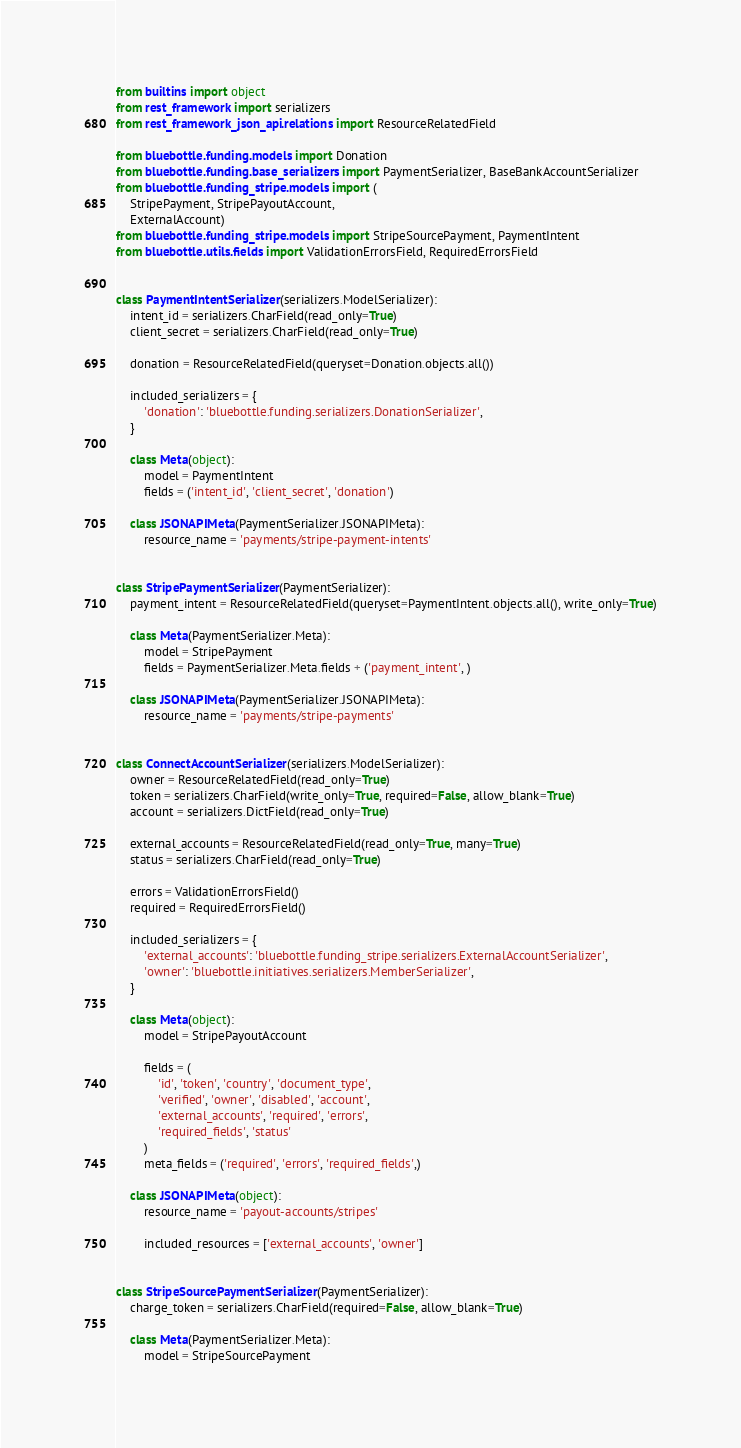Convert code to text. <code><loc_0><loc_0><loc_500><loc_500><_Python_>from builtins import object
from rest_framework import serializers
from rest_framework_json_api.relations import ResourceRelatedField

from bluebottle.funding.models import Donation
from bluebottle.funding.base_serializers import PaymentSerializer, BaseBankAccountSerializer
from bluebottle.funding_stripe.models import (
    StripePayment, StripePayoutAccount,
    ExternalAccount)
from bluebottle.funding_stripe.models import StripeSourcePayment, PaymentIntent
from bluebottle.utils.fields import ValidationErrorsField, RequiredErrorsField


class PaymentIntentSerializer(serializers.ModelSerializer):
    intent_id = serializers.CharField(read_only=True)
    client_secret = serializers.CharField(read_only=True)

    donation = ResourceRelatedField(queryset=Donation.objects.all())

    included_serializers = {
        'donation': 'bluebottle.funding.serializers.DonationSerializer',
    }

    class Meta(object):
        model = PaymentIntent
        fields = ('intent_id', 'client_secret', 'donation')

    class JSONAPIMeta(PaymentSerializer.JSONAPIMeta):
        resource_name = 'payments/stripe-payment-intents'


class StripePaymentSerializer(PaymentSerializer):
    payment_intent = ResourceRelatedField(queryset=PaymentIntent.objects.all(), write_only=True)

    class Meta(PaymentSerializer.Meta):
        model = StripePayment
        fields = PaymentSerializer.Meta.fields + ('payment_intent', )

    class JSONAPIMeta(PaymentSerializer.JSONAPIMeta):
        resource_name = 'payments/stripe-payments'


class ConnectAccountSerializer(serializers.ModelSerializer):
    owner = ResourceRelatedField(read_only=True)
    token = serializers.CharField(write_only=True, required=False, allow_blank=True)
    account = serializers.DictField(read_only=True)

    external_accounts = ResourceRelatedField(read_only=True, many=True)
    status = serializers.CharField(read_only=True)

    errors = ValidationErrorsField()
    required = RequiredErrorsField()

    included_serializers = {
        'external_accounts': 'bluebottle.funding_stripe.serializers.ExternalAccountSerializer',
        'owner': 'bluebottle.initiatives.serializers.MemberSerializer',
    }

    class Meta(object):
        model = StripePayoutAccount

        fields = (
            'id', 'token', 'country', 'document_type',
            'verified', 'owner', 'disabled', 'account',
            'external_accounts', 'required', 'errors',
            'required_fields', 'status'
        )
        meta_fields = ('required', 'errors', 'required_fields',)

    class JSONAPIMeta(object):
        resource_name = 'payout-accounts/stripes'

        included_resources = ['external_accounts', 'owner']


class StripeSourcePaymentSerializer(PaymentSerializer):
    charge_token = serializers.CharField(required=False, allow_blank=True)

    class Meta(PaymentSerializer.Meta):
        model = StripeSourcePayment</code> 